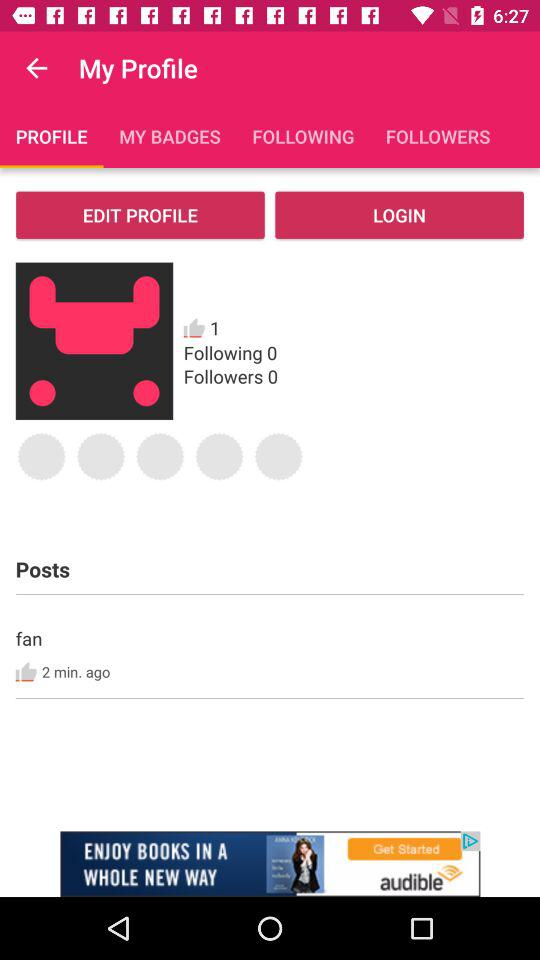How many followers are there? There are 0 followers. 